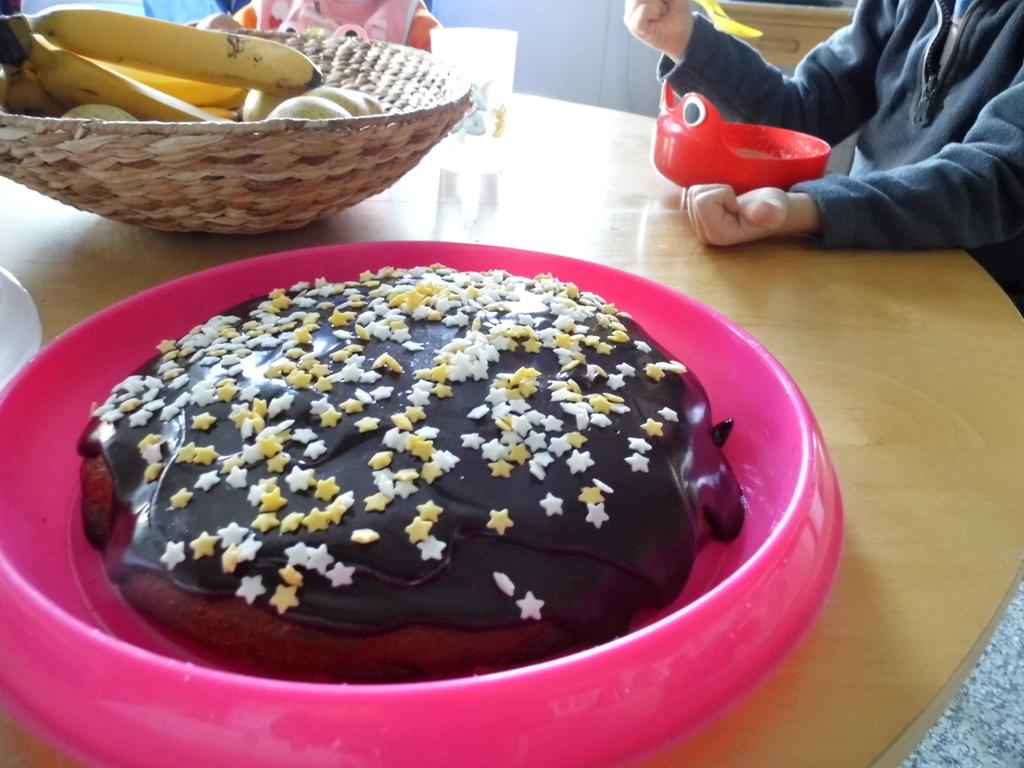What piece of furniture is present in the image? There is a table in the image. What is on the table? There is a pink color plate on the table, and there is a cake in the plate. What type of fruit can be seen in the image? There are bananas in the image. Where is the person sitting in relation to the table? The person is sitting at the right side of the table. What type of flag is being waved by the person sitting at the table? There is no flag present in the image, and the person is not waving anything. 